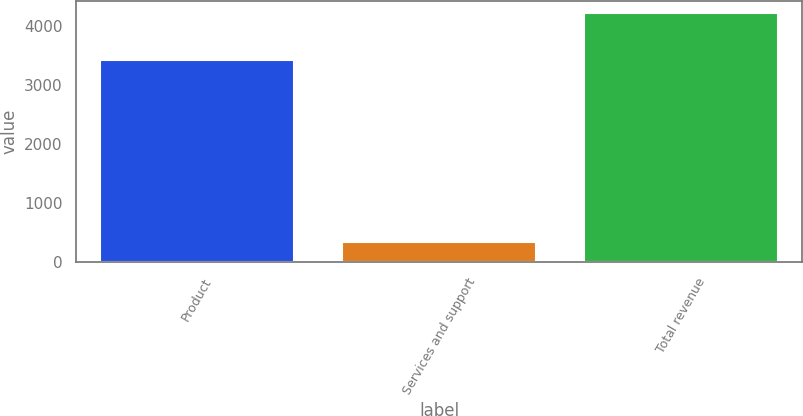Convert chart. <chart><loc_0><loc_0><loc_500><loc_500><bar_chart><fcel>Product<fcel>Services and support<fcel>Total revenue<nl><fcel>3424.5<fcel>341.1<fcel>4216.3<nl></chart> 